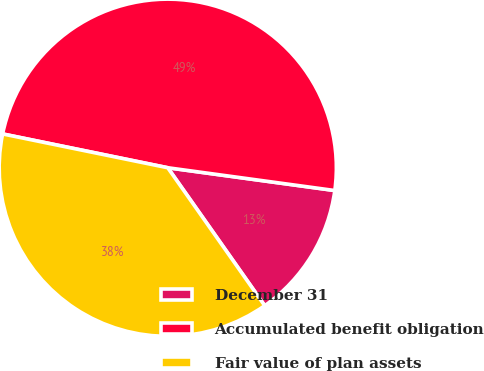Convert chart to OTSL. <chart><loc_0><loc_0><loc_500><loc_500><pie_chart><fcel>December 31<fcel>Accumulated benefit obligation<fcel>Fair value of plan assets<nl><fcel>13.09%<fcel>48.95%<fcel>37.97%<nl></chart> 